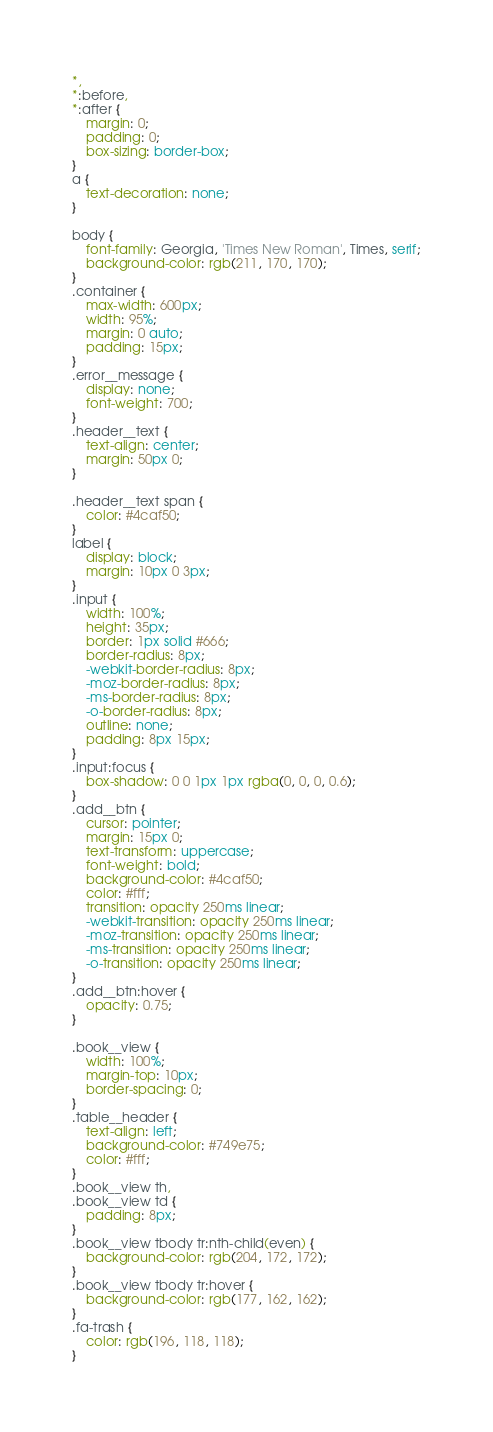<code> <loc_0><loc_0><loc_500><loc_500><_CSS_>*,
*:before,
*:after {
	margin: 0;
	padding: 0;
	box-sizing: border-box;
}
a {
	text-decoration: none;
}

body {
	font-family: Georgia, 'Times New Roman', Times, serif;
	background-color: rgb(211, 170, 170);
}
.container {
	max-width: 600px;
	width: 95%;
	margin: 0 auto;
	padding: 15px;
}
.error__message {
	display: none;
	font-weight: 700;
}
.header__text {
	text-align: center;
	margin: 50px 0;
}

.header__text span {
	color: #4caf50;
}
label {
	display: block;
	margin: 10px 0 3px;
}
.input {
	width: 100%;
	height: 35px;
	border: 1px solid #666;
	border-radius: 8px;
	-webkit-border-radius: 8px;
	-moz-border-radius: 8px;
	-ms-border-radius: 8px;
	-o-border-radius: 8px;
	outline: none;
	padding: 8px 15px;
}
.input:focus {
	box-shadow: 0 0 1px 1px rgba(0, 0, 0, 0.6);
}
.add__btn {
	cursor: pointer;
	margin: 15px 0;
	text-transform: uppercase;
	font-weight: bold;
	background-color: #4caf50;
	color: #fff;
	transition: opacity 250ms linear;
	-webkit-transition: opacity 250ms linear;
	-moz-transition: opacity 250ms linear;
	-ms-transition: opacity 250ms linear;
	-o-transition: opacity 250ms linear;
}
.add__btn:hover {
	opacity: 0.75;
}

.book__view {
	width: 100%;
	margin-top: 10px;
	border-spacing: 0;
}
.table__header {
	text-align: left;
	background-color: #749e75;
	color: #fff;
}
.book__view th,
.book__view td {
	padding: 8px;
}
.book__view tbody tr:nth-child(even) {
	background-color: rgb(204, 172, 172);
}
.book__view tbody tr:hover {
	background-color: rgb(177, 162, 162);
}
.fa-trash {
	color: rgb(196, 118, 118);
}
</code> 